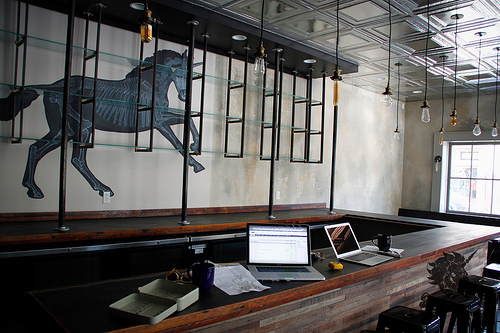<image>
Can you confirm if the light is behind the horse painting? No. The light is not behind the horse painting. From this viewpoint, the light appears to be positioned elsewhere in the scene. 